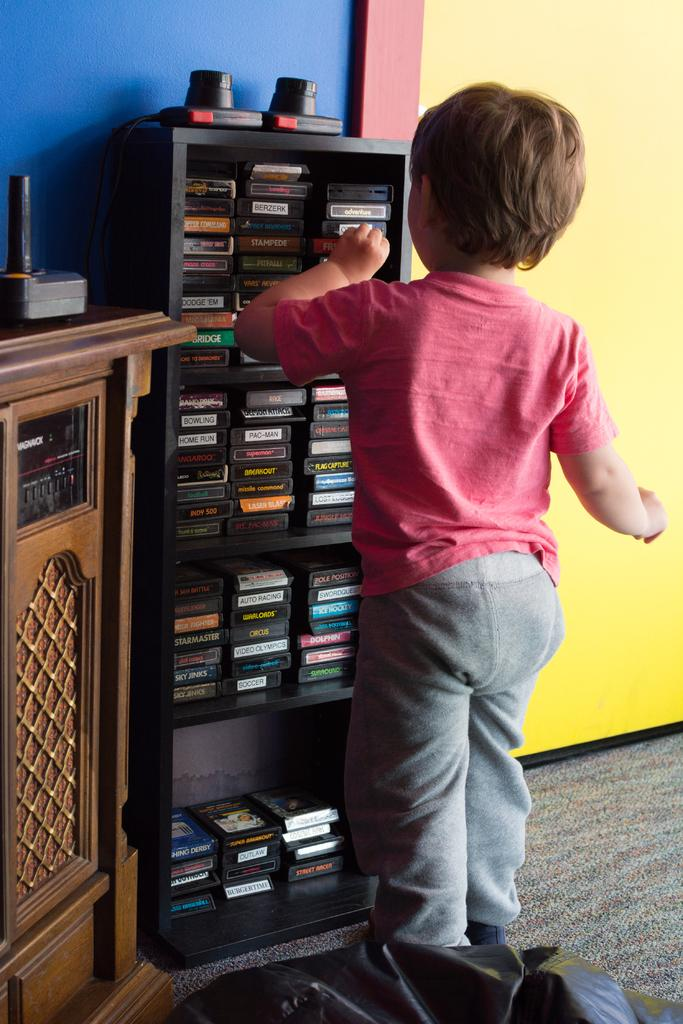Who is the main subject in the image? There is a boy in the image. What is the boy doing in the image? The boy is picking up something. Can you describe any other objects or structures in the image? There is a wooden shelf in the image. What type of cork can be seen on the wooden shelf in the image? There is no cork present on the wooden shelf in the image. How much change is the boy holding in the image? There is no mention of change or money in the image; the boy is picking up something unspecified. 